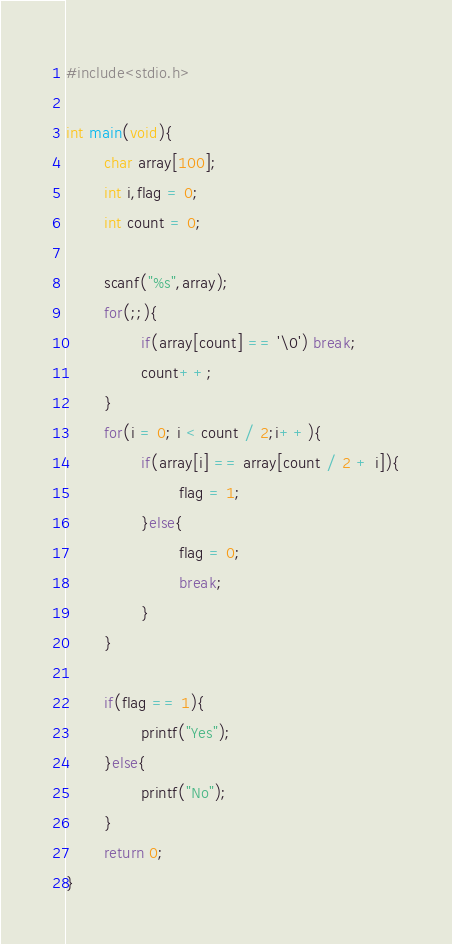<code> <loc_0><loc_0><loc_500><loc_500><_C_>#include<stdio.h>

int main(void){
        char array[100];
        int i,flag = 0;
        int count = 0;

        scanf("%s",array);
        for(;;){
                if(array[count] == '\0') break;
                count++;
        }
        for(i = 0; i < count / 2;i++){
                if(array[i] == array[count / 2 + i]){
                        flag = 1;
                }else{
                        flag = 0;
                        break;
                } 
        }

        if(flag == 1){
                printf("Yes");
        }else{
                printf("No");
        }
        return 0;
}


</code> 